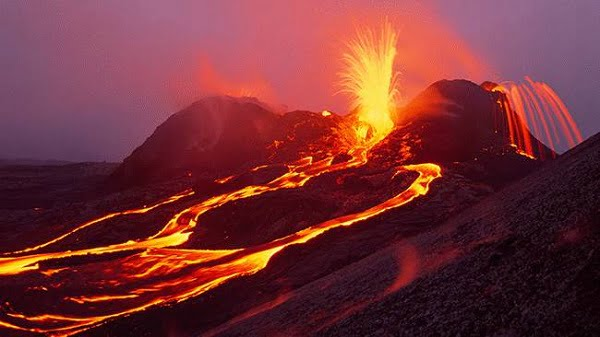Describe the types of research carried out by scientists in volcanic areas like this. Scientific research in volcanic areas typically includes studying magma composition, eruption patterns, and geological history to better understand and predict future volcanic activity. Researchers also examine the impact of eruptions on the atmosphere and climate, as well as biological studies on how ecosystems recover post-eruption. Advanced technologies like drones, satellite imagery, and seismic sensors are commonly used for collecting data in these hazardous environments. 